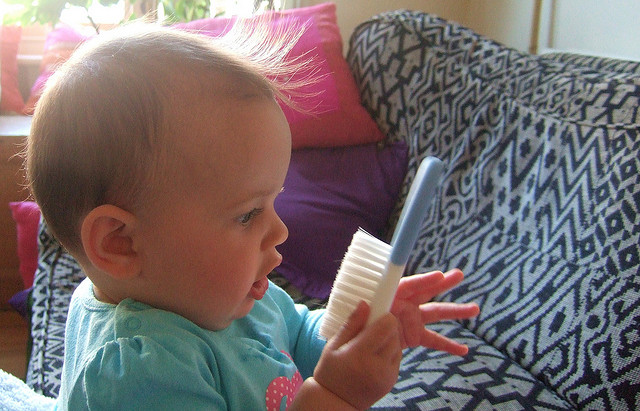What are some other everyday items that can be used to stimulate a child's curiosity safely? Everyday items such as soft books with varied textures, rattles, rubber balls, and large, colorful wooden spoons can be excellent for stimulating a child's curiosity. These items are safe for exploration and can help children discover the world around them through different shapes, sizes, and sounds, promoting both cognitive and physical development. 